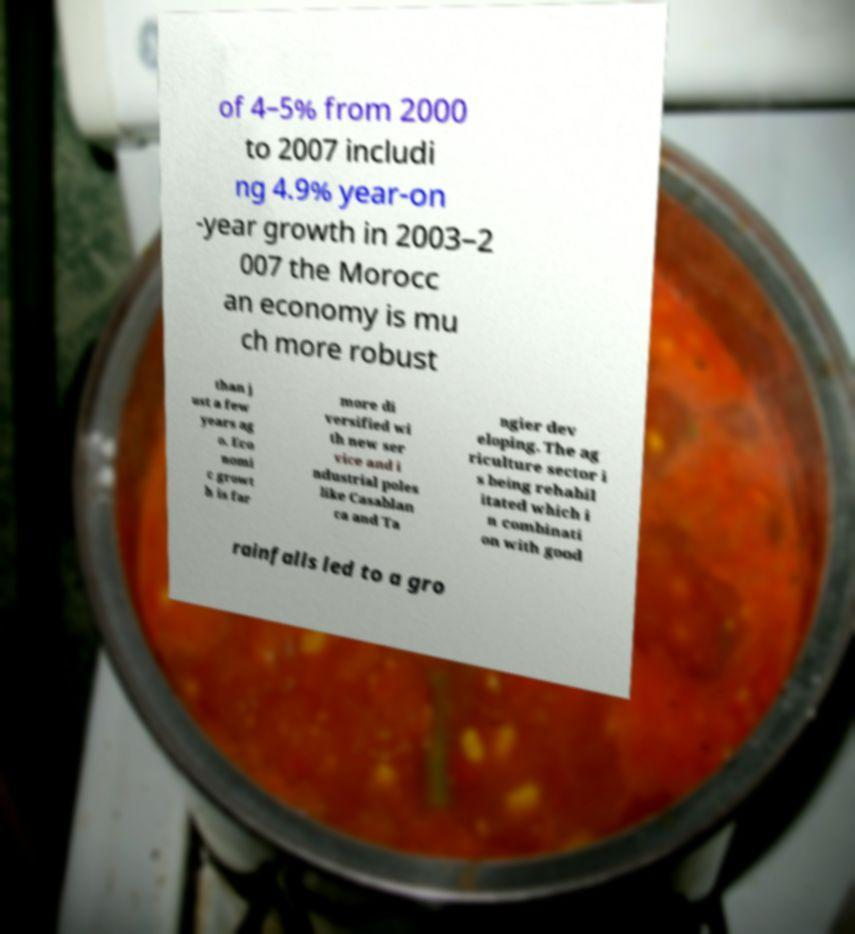Could you assist in decoding the text presented in this image and type it out clearly? of 4–5% from 2000 to 2007 includi ng 4.9% year-on -year growth in 2003–2 007 the Morocc an economy is mu ch more robust than j ust a few years ag o. Eco nomi c growt h is far more di versified wi th new ser vice and i ndustrial poles like Casablan ca and Ta ngier dev eloping. The ag riculture sector i s being rehabil itated which i n combinati on with good rainfalls led to a gro 